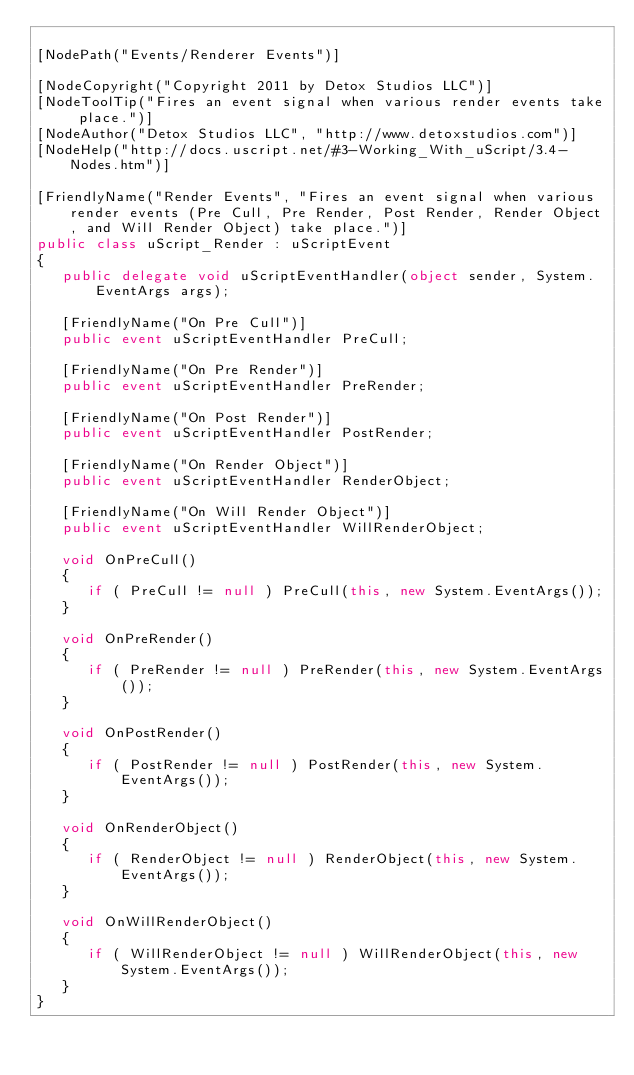<code> <loc_0><loc_0><loc_500><loc_500><_C#_>
[NodePath("Events/Renderer Events")]

[NodeCopyright("Copyright 2011 by Detox Studios LLC")]
[NodeToolTip("Fires an event signal when various render events take place.")]
[NodeAuthor("Detox Studios LLC", "http://www.detoxstudios.com")]
[NodeHelp("http://docs.uscript.net/#3-Working_With_uScript/3.4-Nodes.htm")]

[FriendlyName("Render Events", "Fires an event signal when various render events (Pre Cull, Pre Render, Post Render, Render Object, and Will Render Object) take place.")]
public class uScript_Render : uScriptEvent
{
   public delegate void uScriptEventHandler(object sender, System.EventArgs args);
   
   [FriendlyName("On Pre Cull")]
   public event uScriptEventHandler PreCull;

   [FriendlyName("On Pre Render")]
   public event uScriptEventHandler PreRender;

   [FriendlyName("On Post Render")]
   public event uScriptEventHandler PostRender;

   [FriendlyName("On Render Object")]
   public event uScriptEventHandler RenderObject;

   [FriendlyName("On Will Render Object")]
   public event uScriptEventHandler WillRenderObject;

   void OnPreCull()
   {
      if ( PreCull != null ) PreCull(this, new System.EventArgs());
   }

   void OnPreRender()
   {
      if ( PreRender != null ) PreRender(this, new System.EventArgs());
   }

   void OnPostRender()
   {
      if ( PostRender != null ) PostRender(this, new System.EventArgs());
   }

   void OnRenderObject()
   {
      if ( RenderObject != null ) RenderObject(this, new System.EventArgs());
   }

   void OnWillRenderObject()
   {
      if ( WillRenderObject != null ) WillRenderObject(this, new System.EventArgs());
   }
}
</code> 